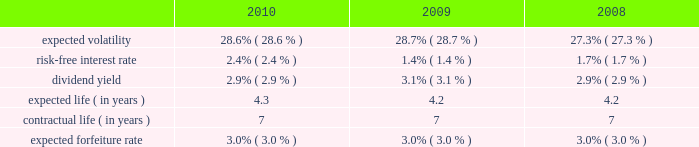2006 plan prior to december 5 , 2008 became fully vested and nonforfeitable upon the closing of the acquisition .
Awards may be granted under the 2006 plan , as amended and restated , after december 5 , 2008 only to employees and consultants of allied waste industries , inc .
And its subsidiaries who were not employed by republic services , inc .
Prior to such date .
At december 31 , 2010 , there were approximately 15.3 million shares of common stock reserved for future grants under the 2006 plan .
Stock options we use a binomial option-pricing model to value our stock option grants .
We recognize compensation expense on a straight-line basis over the requisite service period for each separately vesting portion of the award , or to the employee 2019s retirement eligible date , if earlier .
Expected volatility is based on the weighted average of the most recent one-year volatility and a historical rolling average volatility of our stock over the expected life of the option .
The risk-free interest rate is based on federal reserve rates in effect for bonds with maturity dates equal to the expected term of the option .
We use historical data to estimate future option exercises , forfeitures and expected life of the options .
When appropriate , separate groups of employees that have similar historical exercise behavior are considered separately for valuation purposes .
The weighted-average estimated fair values of stock options granted during the years ended december 31 , 2010 , 2009 and 2008 were $ 5.28 , $ 3.79 and $ 4.36 per option , respectively , which were calculated using the following weighted-average assumptions: .
Republic services , inc .
Notes to consolidated financial statements , continued .
From 2009 to 2010 what was the percentage change in the expected volatility? 
Rationale: from 2009 to 2010 what was the percentage change in the expected volatility increased by 5.2%
Computations: ((28.7 - 27.3) / 27.3)
Answer: 0.05128. 